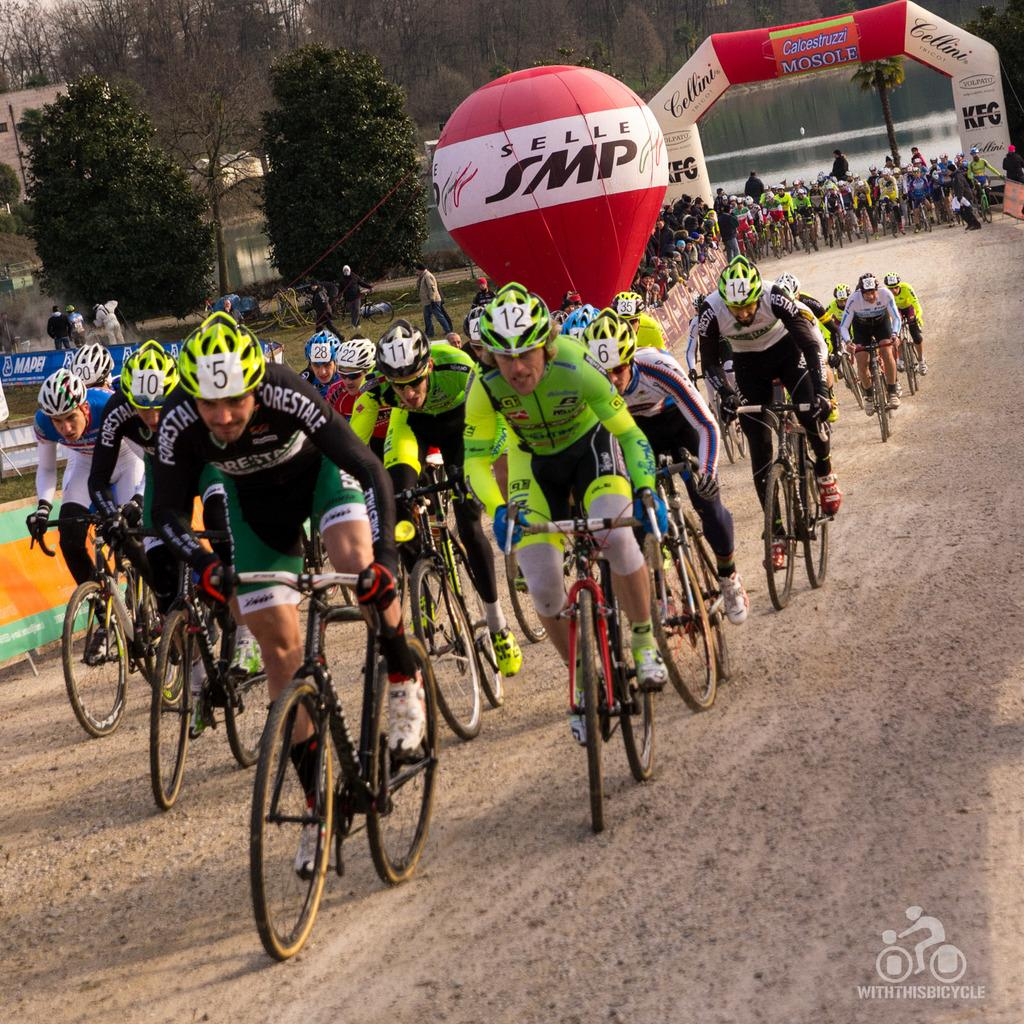What activity is taking place in the image? There is a competition depicted in the image. What type of vehicles are the participants using? Many people are riding bicycles in the competition. What can be seen in the background of the image? There are trees and other people visible in the background. What additional elements are present in the image? Banners and a balloon are visible in the image. What is the setting of the competition? There is a water surface in the image, which suggests that the competition might be taking place near a body of water. What type of jam is being served to the participants during the competition? There is no jam present in the image, and it is not mentioned that any food or beverages are being served. 